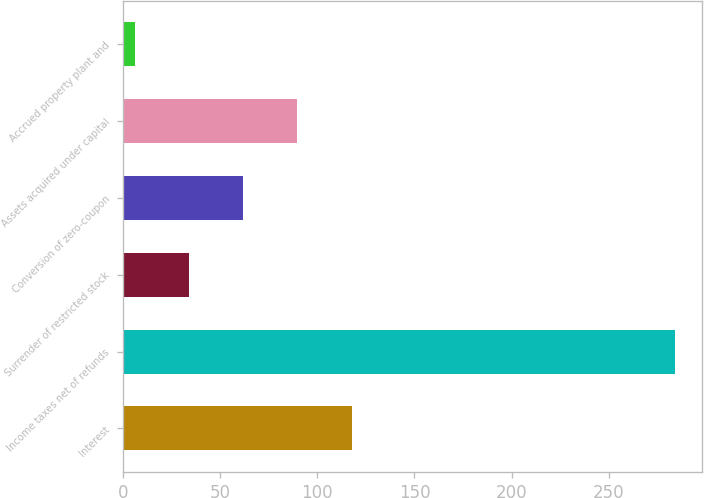Convert chart to OTSL. <chart><loc_0><loc_0><loc_500><loc_500><bar_chart><fcel>Interest<fcel>Income taxes net of refunds<fcel>Surrender of restricted stock<fcel>Conversion of zero-coupon<fcel>Assets acquired under capital<fcel>Accrued property plant and<nl><fcel>117.8<fcel>284.1<fcel>33.99<fcel>61.78<fcel>89.57<fcel>6.2<nl></chart> 